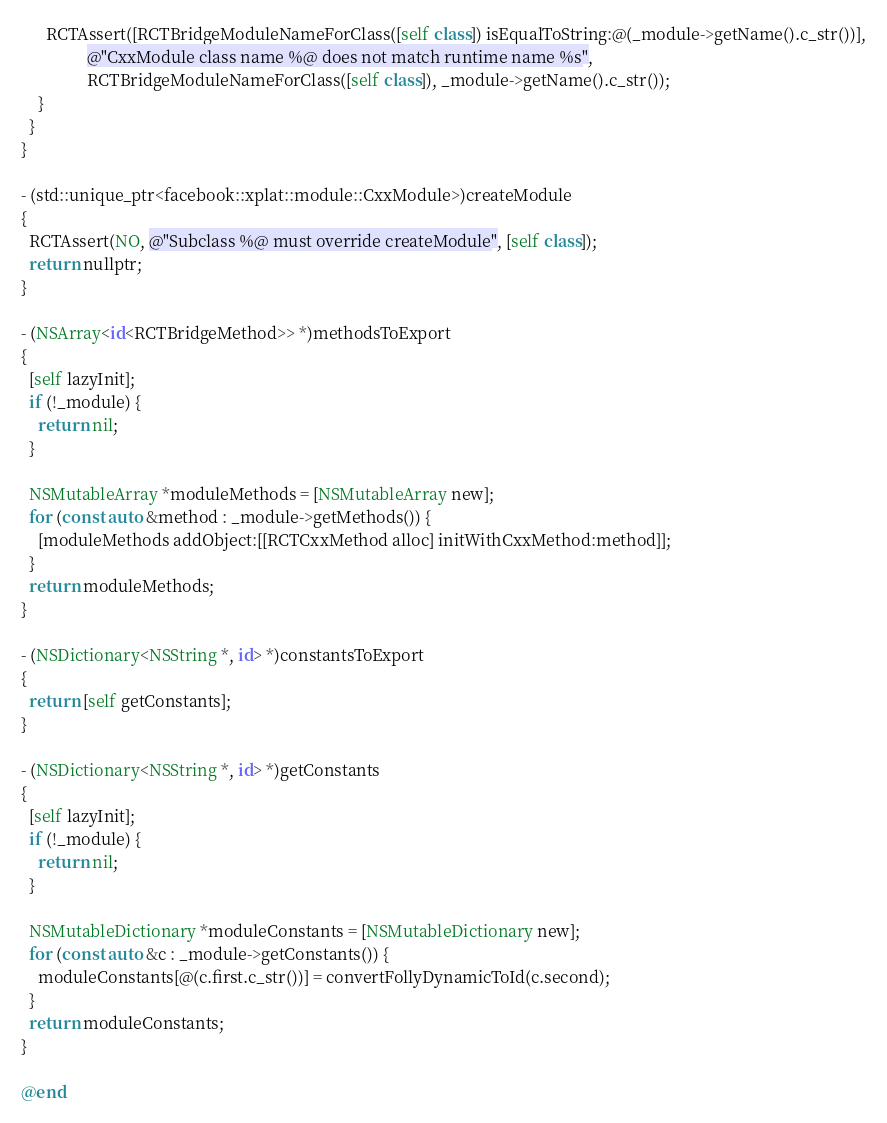Convert code to text. <code><loc_0><loc_0><loc_500><loc_500><_ObjectiveC_>      RCTAssert([RCTBridgeModuleNameForClass([self class]) isEqualToString:@(_module->getName().c_str())],
                @"CxxModule class name %@ does not match runtime name %s",
                RCTBridgeModuleNameForClass([self class]), _module->getName().c_str());
    }
  }
}

- (std::unique_ptr<facebook::xplat::module::CxxModule>)createModule
{
  RCTAssert(NO, @"Subclass %@ must override createModule", [self class]);
  return nullptr;
}

- (NSArray<id<RCTBridgeMethod>> *)methodsToExport
{
  [self lazyInit];
  if (!_module) {
    return nil;
  }

  NSMutableArray *moduleMethods = [NSMutableArray new];
  for (const auto &method : _module->getMethods()) {
    [moduleMethods addObject:[[RCTCxxMethod alloc] initWithCxxMethod:method]];
  }
  return moduleMethods;
}

- (NSDictionary<NSString *, id> *)constantsToExport
{
  return [self getConstants];
}

- (NSDictionary<NSString *, id> *)getConstants
{
  [self lazyInit];
  if (!_module) {
    return nil;
  }

  NSMutableDictionary *moduleConstants = [NSMutableDictionary new];
  for (const auto &c : _module->getConstants()) {
    moduleConstants[@(c.first.c_str())] = convertFollyDynamicToId(c.second);
  }
  return moduleConstants;
}

@end
</code> 